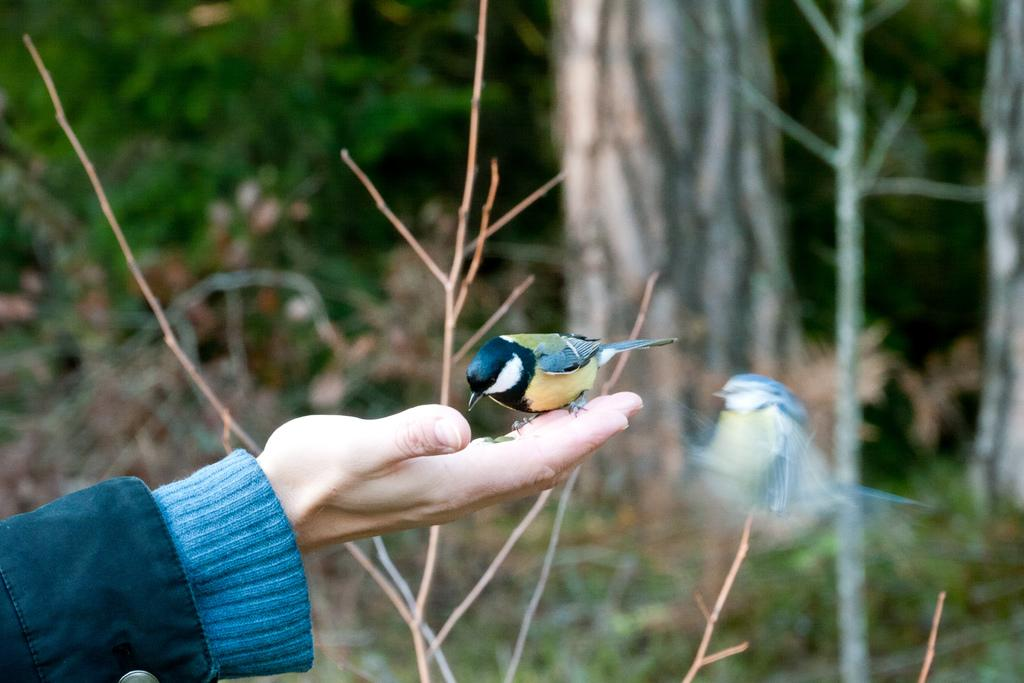What is happening with the bird in the image? There is a bird on a person's hand in the image, and another bird is flying in the air near the person's hand. What can be seen in the background of the image? There are bare plants and trees in the background of the image. What type of agreement is being discussed between the birds in the image? There is no indication in the image that the birds are discussing any agreements. 